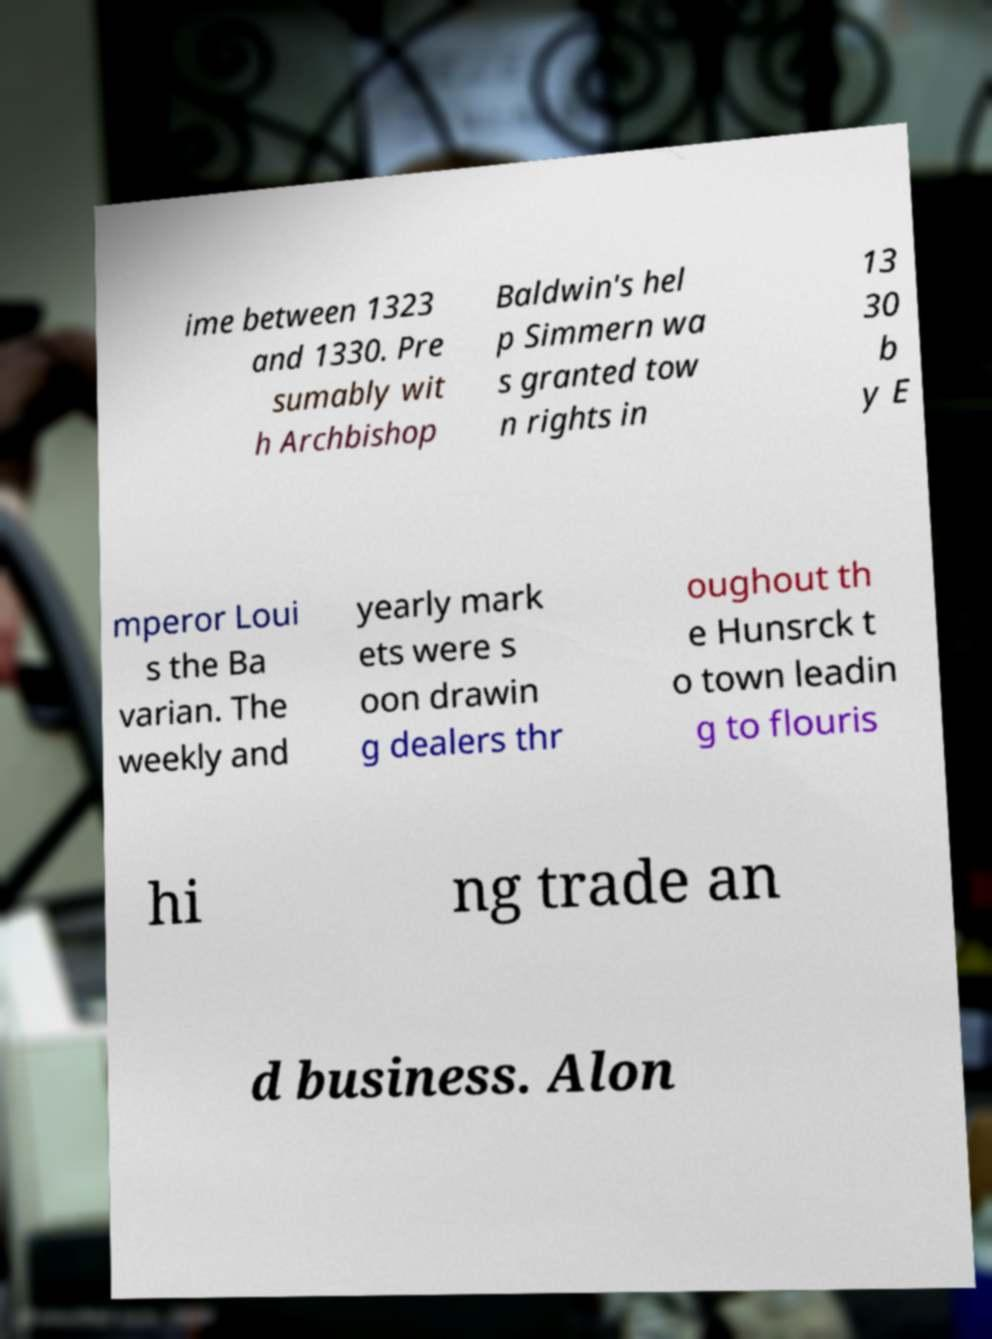Can you read and provide the text displayed in the image?This photo seems to have some interesting text. Can you extract and type it out for me? ime between 1323 and 1330. Pre sumably wit h Archbishop Baldwin's hel p Simmern wa s granted tow n rights in 13 30 b y E mperor Loui s the Ba varian. The weekly and yearly mark ets were s oon drawin g dealers thr oughout th e Hunsrck t o town leadin g to flouris hi ng trade an d business. Alon 